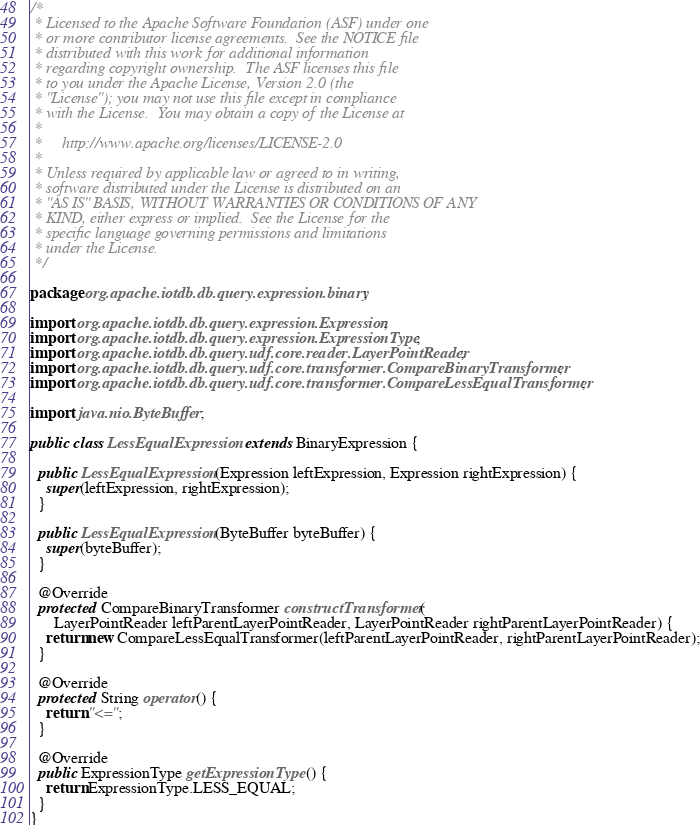Convert code to text. <code><loc_0><loc_0><loc_500><loc_500><_Java_>/*
 * Licensed to the Apache Software Foundation (ASF) under one
 * or more contributor license agreements.  See the NOTICE file
 * distributed with this work for additional information
 * regarding copyright ownership.  The ASF licenses this file
 * to you under the Apache License, Version 2.0 (the
 * "License"); you may not use this file except in compliance
 * with the License.  You may obtain a copy of the License at
 *
 *     http://www.apache.org/licenses/LICENSE-2.0
 *
 * Unless required by applicable law or agreed to in writing,
 * software distributed under the License is distributed on an
 * "AS IS" BASIS, WITHOUT WARRANTIES OR CONDITIONS OF ANY
 * KIND, either express or implied.  See the License for the
 * specific language governing permissions and limitations
 * under the License.
 */

package org.apache.iotdb.db.query.expression.binary;

import org.apache.iotdb.db.query.expression.Expression;
import org.apache.iotdb.db.query.expression.ExpressionType;
import org.apache.iotdb.db.query.udf.core.reader.LayerPointReader;
import org.apache.iotdb.db.query.udf.core.transformer.CompareBinaryTransformer;
import org.apache.iotdb.db.query.udf.core.transformer.CompareLessEqualTransformer;

import java.nio.ByteBuffer;

public class LessEqualExpression extends BinaryExpression {

  public LessEqualExpression(Expression leftExpression, Expression rightExpression) {
    super(leftExpression, rightExpression);
  }

  public LessEqualExpression(ByteBuffer byteBuffer) {
    super(byteBuffer);
  }

  @Override
  protected CompareBinaryTransformer constructTransformer(
      LayerPointReader leftParentLayerPointReader, LayerPointReader rightParentLayerPointReader) {
    return new CompareLessEqualTransformer(leftParentLayerPointReader, rightParentLayerPointReader);
  }

  @Override
  protected String operator() {
    return "<=";
  }

  @Override
  public ExpressionType getExpressionType() {
    return ExpressionType.LESS_EQUAL;
  }
}
</code> 